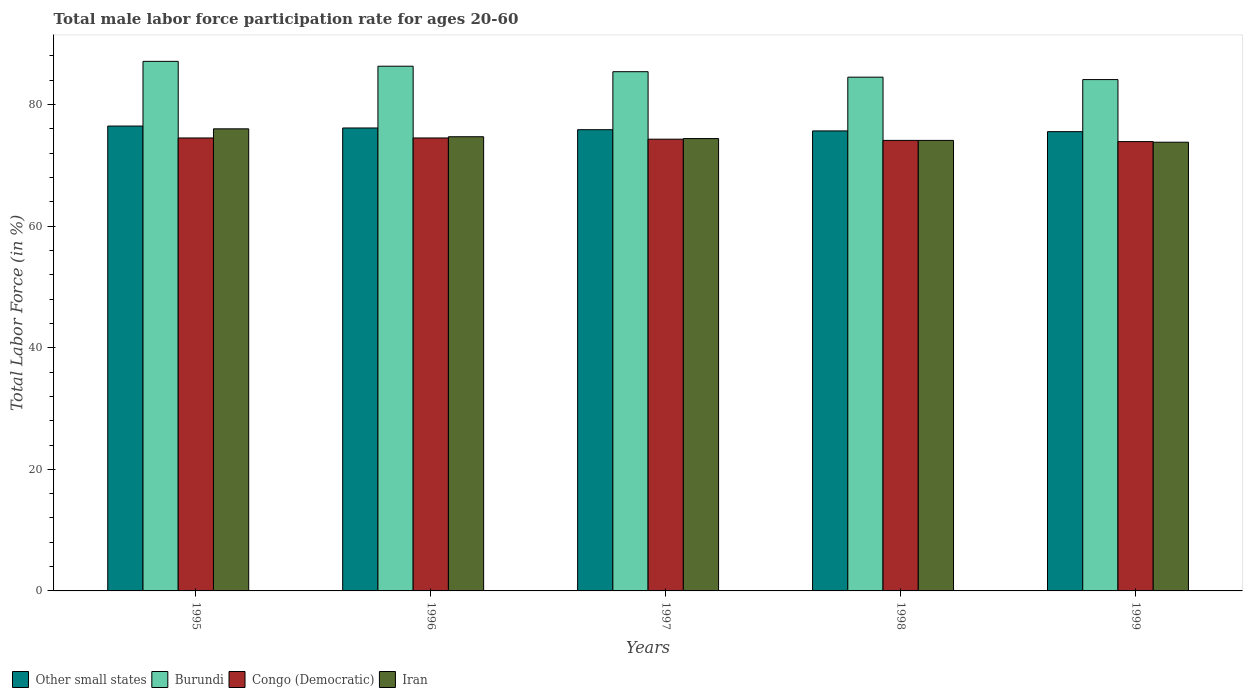How many groups of bars are there?
Offer a terse response. 5. How many bars are there on the 2nd tick from the right?
Keep it short and to the point. 4. What is the male labor force participation rate in Other small states in 1995?
Provide a succinct answer. 76.46. Across all years, what is the maximum male labor force participation rate in Other small states?
Provide a succinct answer. 76.46. Across all years, what is the minimum male labor force participation rate in Congo (Democratic)?
Your answer should be compact. 73.9. What is the total male labor force participation rate in Burundi in the graph?
Provide a succinct answer. 427.4. What is the difference between the male labor force participation rate in Congo (Democratic) in 1995 and that in 1998?
Provide a short and direct response. 0.4. What is the difference between the male labor force participation rate in Iran in 1998 and the male labor force participation rate in Other small states in 1996?
Keep it short and to the point. -2.04. What is the average male labor force participation rate in Other small states per year?
Give a very brief answer. 75.93. In the year 1995, what is the difference between the male labor force participation rate in Iran and male labor force participation rate in Burundi?
Your response must be concise. -11.1. In how many years, is the male labor force participation rate in Congo (Democratic) greater than 84 %?
Keep it short and to the point. 0. What is the ratio of the male labor force participation rate in Other small states in 1996 to that in 1997?
Provide a short and direct response. 1. Is the male labor force participation rate in Congo (Democratic) in 1997 less than that in 1999?
Your answer should be compact. No. Is the difference between the male labor force participation rate in Iran in 1997 and 1999 greater than the difference between the male labor force participation rate in Burundi in 1997 and 1999?
Offer a terse response. No. What is the difference between the highest and the second highest male labor force participation rate in Other small states?
Your response must be concise. 0.32. What is the difference between the highest and the lowest male labor force participation rate in Congo (Democratic)?
Ensure brevity in your answer.  0.6. What does the 4th bar from the left in 1995 represents?
Your answer should be very brief. Iran. What does the 2nd bar from the right in 1997 represents?
Offer a very short reply. Congo (Democratic). Is it the case that in every year, the sum of the male labor force participation rate in Burundi and male labor force participation rate in Congo (Democratic) is greater than the male labor force participation rate in Iran?
Keep it short and to the point. Yes. How many bars are there?
Provide a succinct answer. 20. How many years are there in the graph?
Your response must be concise. 5. What is the difference between two consecutive major ticks on the Y-axis?
Ensure brevity in your answer.  20. Does the graph contain grids?
Provide a succinct answer. No. How many legend labels are there?
Give a very brief answer. 4. What is the title of the graph?
Provide a short and direct response. Total male labor force participation rate for ages 20-60. What is the Total Labor Force (in %) of Other small states in 1995?
Offer a terse response. 76.46. What is the Total Labor Force (in %) in Burundi in 1995?
Ensure brevity in your answer.  87.1. What is the Total Labor Force (in %) in Congo (Democratic) in 1995?
Your answer should be very brief. 74.5. What is the Total Labor Force (in %) of Iran in 1995?
Your answer should be compact. 76. What is the Total Labor Force (in %) of Other small states in 1996?
Offer a very short reply. 76.14. What is the Total Labor Force (in %) in Burundi in 1996?
Make the answer very short. 86.3. What is the Total Labor Force (in %) of Congo (Democratic) in 1996?
Provide a short and direct response. 74.5. What is the Total Labor Force (in %) of Iran in 1996?
Keep it short and to the point. 74.7. What is the Total Labor Force (in %) of Other small states in 1997?
Offer a very short reply. 75.86. What is the Total Labor Force (in %) in Burundi in 1997?
Give a very brief answer. 85.4. What is the Total Labor Force (in %) in Congo (Democratic) in 1997?
Your response must be concise. 74.3. What is the Total Labor Force (in %) in Iran in 1997?
Your answer should be compact. 74.4. What is the Total Labor Force (in %) of Other small states in 1998?
Ensure brevity in your answer.  75.66. What is the Total Labor Force (in %) of Burundi in 1998?
Your response must be concise. 84.5. What is the Total Labor Force (in %) in Congo (Democratic) in 1998?
Provide a succinct answer. 74.1. What is the Total Labor Force (in %) in Iran in 1998?
Offer a terse response. 74.1. What is the Total Labor Force (in %) in Other small states in 1999?
Make the answer very short. 75.54. What is the Total Labor Force (in %) in Burundi in 1999?
Give a very brief answer. 84.1. What is the Total Labor Force (in %) in Congo (Democratic) in 1999?
Keep it short and to the point. 73.9. What is the Total Labor Force (in %) of Iran in 1999?
Provide a succinct answer. 73.8. Across all years, what is the maximum Total Labor Force (in %) of Other small states?
Offer a very short reply. 76.46. Across all years, what is the maximum Total Labor Force (in %) in Burundi?
Provide a short and direct response. 87.1. Across all years, what is the maximum Total Labor Force (in %) in Congo (Democratic)?
Make the answer very short. 74.5. Across all years, what is the minimum Total Labor Force (in %) of Other small states?
Your answer should be compact. 75.54. Across all years, what is the minimum Total Labor Force (in %) of Burundi?
Make the answer very short. 84.1. Across all years, what is the minimum Total Labor Force (in %) in Congo (Democratic)?
Provide a short and direct response. 73.9. Across all years, what is the minimum Total Labor Force (in %) in Iran?
Give a very brief answer. 73.8. What is the total Total Labor Force (in %) in Other small states in the graph?
Your answer should be compact. 379.65. What is the total Total Labor Force (in %) in Burundi in the graph?
Ensure brevity in your answer.  427.4. What is the total Total Labor Force (in %) of Congo (Democratic) in the graph?
Offer a very short reply. 371.3. What is the total Total Labor Force (in %) of Iran in the graph?
Your answer should be very brief. 373. What is the difference between the Total Labor Force (in %) of Other small states in 1995 and that in 1996?
Make the answer very short. 0.32. What is the difference between the Total Labor Force (in %) in Congo (Democratic) in 1995 and that in 1996?
Your response must be concise. 0. What is the difference between the Total Labor Force (in %) of Other small states in 1995 and that in 1997?
Your answer should be compact. 0.6. What is the difference between the Total Labor Force (in %) in Burundi in 1995 and that in 1997?
Give a very brief answer. 1.7. What is the difference between the Total Labor Force (in %) of Congo (Democratic) in 1995 and that in 1997?
Provide a succinct answer. 0.2. What is the difference between the Total Labor Force (in %) in Iran in 1995 and that in 1997?
Your response must be concise. 1.6. What is the difference between the Total Labor Force (in %) of Other small states in 1995 and that in 1998?
Ensure brevity in your answer.  0.8. What is the difference between the Total Labor Force (in %) in Iran in 1995 and that in 1998?
Your answer should be compact. 1.9. What is the difference between the Total Labor Force (in %) of Other small states in 1995 and that in 1999?
Keep it short and to the point. 0.92. What is the difference between the Total Labor Force (in %) in Burundi in 1995 and that in 1999?
Your answer should be very brief. 3. What is the difference between the Total Labor Force (in %) in Other small states in 1996 and that in 1997?
Provide a succinct answer. 0.28. What is the difference between the Total Labor Force (in %) in Burundi in 1996 and that in 1997?
Provide a succinct answer. 0.9. What is the difference between the Total Labor Force (in %) in Other small states in 1996 and that in 1998?
Your response must be concise. 0.48. What is the difference between the Total Labor Force (in %) of Burundi in 1996 and that in 1998?
Provide a succinct answer. 1.8. What is the difference between the Total Labor Force (in %) in Congo (Democratic) in 1996 and that in 1998?
Offer a terse response. 0.4. What is the difference between the Total Labor Force (in %) of Other small states in 1996 and that in 1999?
Your response must be concise. 0.6. What is the difference between the Total Labor Force (in %) in Other small states in 1997 and that in 1998?
Your answer should be compact. 0.2. What is the difference between the Total Labor Force (in %) of Burundi in 1997 and that in 1998?
Your answer should be compact. 0.9. What is the difference between the Total Labor Force (in %) of Iran in 1997 and that in 1998?
Your answer should be very brief. 0.3. What is the difference between the Total Labor Force (in %) in Other small states in 1997 and that in 1999?
Give a very brief answer. 0.32. What is the difference between the Total Labor Force (in %) of Iran in 1997 and that in 1999?
Your answer should be very brief. 0.6. What is the difference between the Total Labor Force (in %) in Other small states in 1998 and that in 1999?
Your response must be concise. 0.12. What is the difference between the Total Labor Force (in %) in Burundi in 1998 and that in 1999?
Provide a short and direct response. 0.4. What is the difference between the Total Labor Force (in %) of Other small states in 1995 and the Total Labor Force (in %) of Burundi in 1996?
Provide a succinct answer. -9.84. What is the difference between the Total Labor Force (in %) in Other small states in 1995 and the Total Labor Force (in %) in Congo (Democratic) in 1996?
Your response must be concise. 1.96. What is the difference between the Total Labor Force (in %) of Other small states in 1995 and the Total Labor Force (in %) of Iran in 1996?
Offer a very short reply. 1.76. What is the difference between the Total Labor Force (in %) of Burundi in 1995 and the Total Labor Force (in %) of Congo (Democratic) in 1996?
Provide a short and direct response. 12.6. What is the difference between the Total Labor Force (in %) of Other small states in 1995 and the Total Labor Force (in %) of Burundi in 1997?
Provide a succinct answer. -8.94. What is the difference between the Total Labor Force (in %) in Other small states in 1995 and the Total Labor Force (in %) in Congo (Democratic) in 1997?
Provide a short and direct response. 2.16. What is the difference between the Total Labor Force (in %) in Other small states in 1995 and the Total Labor Force (in %) in Iran in 1997?
Provide a succinct answer. 2.06. What is the difference between the Total Labor Force (in %) of Burundi in 1995 and the Total Labor Force (in %) of Iran in 1997?
Your answer should be very brief. 12.7. What is the difference between the Total Labor Force (in %) in Congo (Democratic) in 1995 and the Total Labor Force (in %) in Iran in 1997?
Your answer should be compact. 0.1. What is the difference between the Total Labor Force (in %) in Other small states in 1995 and the Total Labor Force (in %) in Burundi in 1998?
Your answer should be very brief. -8.04. What is the difference between the Total Labor Force (in %) in Other small states in 1995 and the Total Labor Force (in %) in Congo (Democratic) in 1998?
Your response must be concise. 2.36. What is the difference between the Total Labor Force (in %) in Other small states in 1995 and the Total Labor Force (in %) in Iran in 1998?
Offer a terse response. 2.36. What is the difference between the Total Labor Force (in %) in Burundi in 1995 and the Total Labor Force (in %) in Congo (Democratic) in 1998?
Keep it short and to the point. 13. What is the difference between the Total Labor Force (in %) of Burundi in 1995 and the Total Labor Force (in %) of Iran in 1998?
Offer a very short reply. 13. What is the difference between the Total Labor Force (in %) in Other small states in 1995 and the Total Labor Force (in %) in Burundi in 1999?
Your answer should be very brief. -7.64. What is the difference between the Total Labor Force (in %) in Other small states in 1995 and the Total Labor Force (in %) in Congo (Democratic) in 1999?
Give a very brief answer. 2.56. What is the difference between the Total Labor Force (in %) of Other small states in 1995 and the Total Labor Force (in %) of Iran in 1999?
Provide a short and direct response. 2.66. What is the difference between the Total Labor Force (in %) in Burundi in 1995 and the Total Labor Force (in %) in Congo (Democratic) in 1999?
Give a very brief answer. 13.2. What is the difference between the Total Labor Force (in %) of Burundi in 1995 and the Total Labor Force (in %) of Iran in 1999?
Offer a very short reply. 13.3. What is the difference between the Total Labor Force (in %) in Other small states in 1996 and the Total Labor Force (in %) in Burundi in 1997?
Offer a very short reply. -9.26. What is the difference between the Total Labor Force (in %) of Other small states in 1996 and the Total Labor Force (in %) of Congo (Democratic) in 1997?
Make the answer very short. 1.84. What is the difference between the Total Labor Force (in %) in Other small states in 1996 and the Total Labor Force (in %) in Iran in 1997?
Your answer should be very brief. 1.74. What is the difference between the Total Labor Force (in %) of Burundi in 1996 and the Total Labor Force (in %) of Congo (Democratic) in 1997?
Provide a succinct answer. 12. What is the difference between the Total Labor Force (in %) of Burundi in 1996 and the Total Labor Force (in %) of Iran in 1997?
Offer a very short reply. 11.9. What is the difference between the Total Labor Force (in %) of Other small states in 1996 and the Total Labor Force (in %) of Burundi in 1998?
Your answer should be compact. -8.36. What is the difference between the Total Labor Force (in %) in Other small states in 1996 and the Total Labor Force (in %) in Congo (Democratic) in 1998?
Your response must be concise. 2.04. What is the difference between the Total Labor Force (in %) of Other small states in 1996 and the Total Labor Force (in %) of Iran in 1998?
Give a very brief answer. 2.04. What is the difference between the Total Labor Force (in %) in Burundi in 1996 and the Total Labor Force (in %) in Iran in 1998?
Offer a very short reply. 12.2. What is the difference between the Total Labor Force (in %) in Congo (Democratic) in 1996 and the Total Labor Force (in %) in Iran in 1998?
Provide a short and direct response. 0.4. What is the difference between the Total Labor Force (in %) in Other small states in 1996 and the Total Labor Force (in %) in Burundi in 1999?
Ensure brevity in your answer.  -7.96. What is the difference between the Total Labor Force (in %) of Other small states in 1996 and the Total Labor Force (in %) of Congo (Democratic) in 1999?
Keep it short and to the point. 2.24. What is the difference between the Total Labor Force (in %) in Other small states in 1996 and the Total Labor Force (in %) in Iran in 1999?
Give a very brief answer. 2.34. What is the difference between the Total Labor Force (in %) in Burundi in 1996 and the Total Labor Force (in %) in Congo (Democratic) in 1999?
Ensure brevity in your answer.  12.4. What is the difference between the Total Labor Force (in %) of Other small states in 1997 and the Total Labor Force (in %) of Burundi in 1998?
Ensure brevity in your answer.  -8.64. What is the difference between the Total Labor Force (in %) in Other small states in 1997 and the Total Labor Force (in %) in Congo (Democratic) in 1998?
Your answer should be compact. 1.76. What is the difference between the Total Labor Force (in %) of Other small states in 1997 and the Total Labor Force (in %) of Iran in 1998?
Offer a terse response. 1.76. What is the difference between the Total Labor Force (in %) in Other small states in 1997 and the Total Labor Force (in %) in Burundi in 1999?
Your answer should be compact. -8.24. What is the difference between the Total Labor Force (in %) in Other small states in 1997 and the Total Labor Force (in %) in Congo (Democratic) in 1999?
Provide a short and direct response. 1.96. What is the difference between the Total Labor Force (in %) of Other small states in 1997 and the Total Labor Force (in %) of Iran in 1999?
Provide a short and direct response. 2.06. What is the difference between the Total Labor Force (in %) of Burundi in 1997 and the Total Labor Force (in %) of Iran in 1999?
Provide a succinct answer. 11.6. What is the difference between the Total Labor Force (in %) of Other small states in 1998 and the Total Labor Force (in %) of Burundi in 1999?
Keep it short and to the point. -8.44. What is the difference between the Total Labor Force (in %) of Other small states in 1998 and the Total Labor Force (in %) of Congo (Democratic) in 1999?
Provide a short and direct response. 1.76. What is the difference between the Total Labor Force (in %) of Other small states in 1998 and the Total Labor Force (in %) of Iran in 1999?
Your answer should be compact. 1.86. What is the difference between the Total Labor Force (in %) of Burundi in 1998 and the Total Labor Force (in %) of Congo (Democratic) in 1999?
Make the answer very short. 10.6. What is the average Total Labor Force (in %) of Other small states per year?
Your answer should be compact. 75.93. What is the average Total Labor Force (in %) of Burundi per year?
Your response must be concise. 85.48. What is the average Total Labor Force (in %) of Congo (Democratic) per year?
Your answer should be very brief. 74.26. What is the average Total Labor Force (in %) of Iran per year?
Your response must be concise. 74.6. In the year 1995, what is the difference between the Total Labor Force (in %) of Other small states and Total Labor Force (in %) of Burundi?
Ensure brevity in your answer.  -10.64. In the year 1995, what is the difference between the Total Labor Force (in %) of Other small states and Total Labor Force (in %) of Congo (Democratic)?
Your response must be concise. 1.96. In the year 1995, what is the difference between the Total Labor Force (in %) in Other small states and Total Labor Force (in %) in Iran?
Give a very brief answer. 0.46. In the year 1995, what is the difference between the Total Labor Force (in %) of Burundi and Total Labor Force (in %) of Congo (Democratic)?
Give a very brief answer. 12.6. In the year 1996, what is the difference between the Total Labor Force (in %) of Other small states and Total Labor Force (in %) of Burundi?
Your answer should be compact. -10.16. In the year 1996, what is the difference between the Total Labor Force (in %) of Other small states and Total Labor Force (in %) of Congo (Democratic)?
Ensure brevity in your answer.  1.64. In the year 1996, what is the difference between the Total Labor Force (in %) in Other small states and Total Labor Force (in %) in Iran?
Give a very brief answer. 1.44. In the year 1996, what is the difference between the Total Labor Force (in %) of Burundi and Total Labor Force (in %) of Iran?
Your response must be concise. 11.6. In the year 1997, what is the difference between the Total Labor Force (in %) of Other small states and Total Labor Force (in %) of Burundi?
Ensure brevity in your answer.  -9.54. In the year 1997, what is the difference between the Total Labor Force (in %) of Other small states and Total Labor Force (in %) of Congo (Democratic)?
Provide a short and direct response. 1.56. In the year 1997, what is the difference between the Total Labor Force (in %) of Other small states and Total Labor Force (in %) of Iran?
Provide a succinct answer. 1.46. In the year 1997, what is the difference between the Total Labor Force (in %) in Burundi and Total Labor Force (in %) in Congo (Democratic)?
Your answer should be compact. 11.1. In the year 1997, what is the difference between the Total Labor Force (in %) of Congo (Democratic) and Total Labor Force (in %) of Iran?
Provide a succinct answer. -0.1. In the year 1998, what is the difference between the Total Labor Force (in %) of Other small states and Total Labor Force (in %) of Burundi?
Offer a terse response. -8.84. In the year 1998, what is the difference between the Total Labor Force (in %) of Other small states and Total Labor Force (in %) of Congo (Democratic)?
Provide a short and direct response. 1.56. In the year 1998, what is the difference between the Total Labor Force (in %) in Other small states and Total Labor Force (in %) in Iran?
Keep it short and to the point. 1.56. In the year 1998, what is the difference between the Total Labor Force (in %) of Burundi and Total Labor Force (in %) of Congo (Democratic)?
Your response must be concise. 10.4. In the year 1998, what is the difference between the Total Labor Force (in %) of Burundi and Total Labor Force (in %) of Iran?
Provide a succinct answer. 10.4. In the year 1998, what is the difference between the Total Labor Force (in %) in Congo (Democratic) and Total Labor Force (in %) in Iran?
Offer a very short reply. 0. In the year 1999, what is the difference between the Total Labor Force (in %) of Other small states and Total Labor Force (in %) of Burundi?
Provide a succinct answer. -8.56. In the year 1999, what is the difference between the Total Labor Force (in %) of Other small states and Total Labor Force (in %) of Congo (Democratic)?
Your answer should be compact. 1.64. In the year 1999, what is the difference between the Total Labor Force (in %) of Other small states and Total Labor Force (in %) of Iran?
Ensure brevity in your answer.  1.74. In the year 1999, what is the difference between the Total Labor Force (in %) of Burundi and Total Labor Force (in %) of Congo (Democratic)?
Your answer should be compact. 10.2. What is the ratio of the Total Labor Force (in %) in Burundi in 1995 to that in 1996?
Give a very brief answer. 1.01. What is the ratio of the Total Labor Force (in %) of Congo (Democratic) in 1995 to that in 1996?
Your response must be concise. 1. What is the ratio of the Total Labor Force (in %) in Iran in 1995 to that in 1996?
Provide a succinct answer. 1.02. What is the ratio of the Total Labor Force (in %) in Other small states in 1995 to that in 1997?
Keep it short and to the point. 1.01. What is the ratio of the Total Labor Force (in %) in Burundi in 1995 to that in 1997?
Ensure brevity in your answer.  1.02. What is the ratio of the Total Labor Force (in %) in Congo (Democratic) in 1995 to that in 1997?
Ensure brevity in your answer.  1. What is the ratio of the Total Labor Force (in %) in Iran in 1995 to that in 1997?
Offer a very short reply. 1.02. What is the ratio of the Total Labor Force (in %) in Other small states in 1995 to that in 1998?
Make the answer very short. 1.01. What is the ratio of the Total Labor Force (in %) of Burundi in 1995 to that in 1998?
Your answer should be very brief. 1.03. What is the ratio of the Total Labor Force (in %) in Congo (Democratic) in 1995 to that in 1998?
Ensure brevity in your answer.  1.01. What is the ratio of the Total Labor Force (in %) in Iran in 1995 to that in 1998?
Your response must be concise. 1.03. What is the ratio of the Total Labor Force (in %) of Other small states in 1995 to that in 1999?
Your response must be concise. 1.01. What is the ratio of the Total Labor Force (in %) of Burundi in 1995 to that in 1999?
Offer a terse response. 1.04. What is the ratio of the Total Labor Force (in %) in Congo (Democratic) in 1995 to that in 1999?
Offer a terse response. 1.01. What is the ratio of the Total Labor Force (in %) in Iran in 1995 to that in 1999?
Make the answer very short. 1.03. What is the ratio of the Total Labor Force (in %) of Burundi in 1996 to that in 1997?
Keep it short and to the point. 1.01. What is the ratio of the Total Labor Force (in %) of Other small states in 1996 to that in 1998?
Provide a succinct answer. 1.01. What is the ratio of the Total Labor Force (in %) in Burundi in 1996 to that in 1998?
Give a very brief answer. 1.02. What is the ratio of the Total Labor Force (in %) in Congo (Democratic) in 1996 to that in 1998?
Make the answer very short. 1.01. What is the ratio of the Total Labor Force (in %) of Iran in 1996 to that in 1998?
Provide a succinct answer. 1.01. What is the ratio of the Total Labor Force (in %) in Burundi in 1996 to that in 1999?
Your answer should be very brief. 1.03. What is the ratio of the Total Labor Force (in %) in Iran in 1996 to that in 1999?
Your answer should be compact. 1.01. What is the ratio of the Total Labor Force (in %) in Other small states in 1997 to that in 1998?
Give a very brief answer. 1. What is the ratio of the Total Labor Force (in %) in Burundi in 1997 to that in 1998?
Make the answer very short. 1.01. What is the ratio of the Total Labor Force (in %) of Congo (Democratic) in 1997 to that in 1998?
Give a very brief answer. 1. What is the ratio of the Total Labor Force (in %) in Iran in 1997 to that in 1998?
Your answer should be compact. 1. What is the ratio of the Total Labor Force (in %) of Other small states in 1997 to that in 1999?
Keep it short and to the point. 1. What is the ratio of the Total Labor Force (in %) in Burundi in 1997 to that in 1999?
Provide a short and direct response. 1.02. What is the ratio of the Total Labor Force (in %) in Congo (Democratic) in 1997 to that in 1999?
Your answer should be compact. 1.01. What is the ratio of the Total Labor Force (in %) of Iran in 1998 to that in 1999?
Ensure brevity in your answer.  1. What is the difference between the highest and the second highest Total Labor Force (in %) of Other small states?
Offer a very short reply. 0.32. What is the difference between the highest and the second highest Total Labor Force (in %) of Iran?
Give a very brief answer. 1.3. What is the difference between the highest and the lowest Total Labor Force (in %) of Other small states?
Your response must be concise. 0.92. What is the difference between the highest and the lowest Total Labor Force (in %) of Congo (Democratic)?
Your answer should be compact. 0.6. 